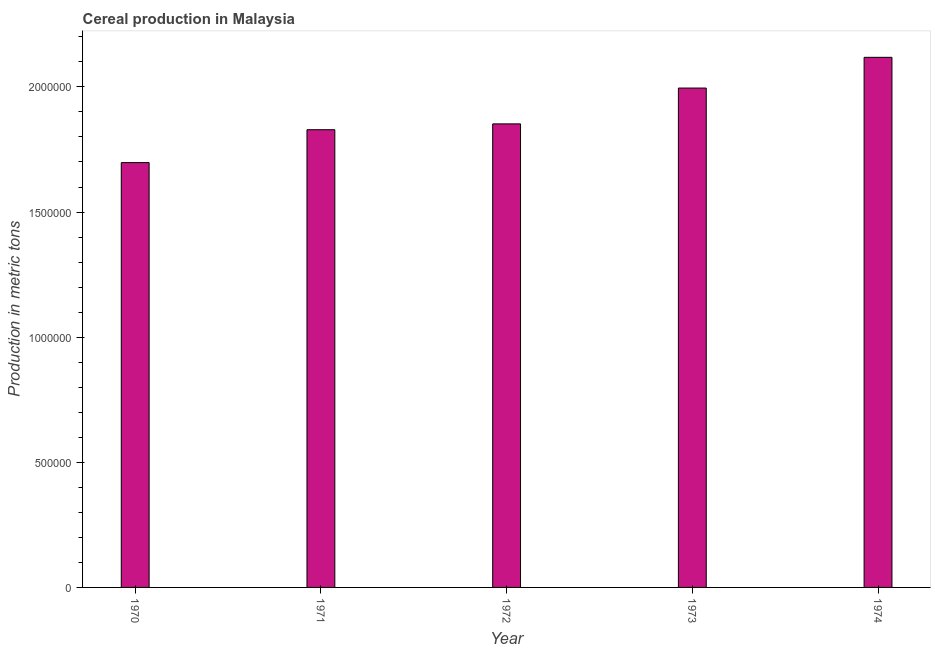Does the graph contain any zero values?
Give a very brief answer. No. What is the title of the graph?
Provide a short and direct response. Cereal production in Malaysia. What is the label or title of the Y-axis?
Provide a succinct answer. Production in metric tons. What is the cereal production in 1970?
Make the answer very short. 1.70e+06. Across all years, what is the maximum cereal production?
Offer a terse response. 2.12e+06. Across all years, what is the minimum cereal production?
Your answer should be compact. 1.70e+06. In which year was the cereal production maximum?
Keep it short and to the point. 1974. What is the sum of the cereal production?
Provide a short and direct response. 9.49e+06. What is the difference between the cereal production in 1971 and 1974?
Your answer should be compact. -2.89e+05. What is the average cereal production per year?
Your answer should be compact. 1.90e+06. What is the median cereal production?
Your answer should be compact. 1.85e+06. What is the ratio of the cereal production in 1973 to that in 1974?
Offer a terse response. 0.94. Is the difference between the cereal production in 1970 and 1972 greater than the difference between any two years?
Your answer should be compact. No. What is the difference between the highest and the second highest cereal production?
Give a very brief answer. 1.23e+05. Is the sum of the cereal production in 1972 and 1974 greater than the maximum cereal production across all years?
Keep it short and to the point. Yes. What is the difference between the highest and the lowest cereal production?
Your answer should be very brief. 4.21e+05. In how many years, is the cereal production greater than the average cereal production taken over all years?
Your answer should be compact. 2. Are all the bars in the graph horizontal?
Offer a terse response. No. How many years are there in the graph?
Your answer should be very brief. 5. What is the difference between two consecutive major ticks on the Y-axis?
Ensure brevity in your answer.  5.00e+05. What is the Production in metric tons of 1970?
Your answer should be very brief. 1.70e+06. What is the Production in metric tons in 1971?
Keep it short and to the point. 1.83e+06. What is the Production in metric tons in 1972?
Make the answer very short. 1.85e+06. What is the Production in metric tons of 1973?
Keep it short and to the point. 2.00e+06. What is the Production in metric tons of 1974?
Your answer should be compact. 2.12e+06. What is the difference between the Production in metric tons in 1970 and 1971?
Keep it short and to the point. -1.31e+05. What is the difference between the Production in metric tons in 1970 and 1972?
Offer a terse response. -1.55e+05. What is the difference between the Production in metric tons in 1970 and 1973?
Ensure brevity in your answer.  -2.98e+05. What is the difference between the Production in metric tons in 1970 and 1974?
Give a very brief answer. -4.21e+05. What is the difference between the Production in metric tons in 1971 and 1972?
Give a very brief answer. -2.33e+04. What is the difference between the Production in metric tons in 1971 and 1973?
Provide a succinct answer. -1.66e+05. What is the difference between the Production in metric tons in 1971 and 1974?
Provide a succinct answer. -2.89e+05. What is the difference between the Production in metric tons in 1972 and 1973?
Ensure brevity in your answer.  -1.43e+05. What is the difference between the Production in metric tons in 1972 and 1974?
Your answer should be very brief. -2.66e+05. What is the difference between the Production in metric tons in 1973 and 1974?
Make the answer very short. -1.23e+05. What is the ratio of the Production in metric tons in 1970 to that in 1971?
Your answer should be compact. 0.93. What is the ratio of the Production in metric tons in 1970 to that in 1972?
Offer a terse response. 0.92. What is the ratio of the Production in metric tons in 1970 to that in 1973?
Make the answer very short. 0.85. What is the ratio of the Production in metric tons in 1970 to that in 1974?
Offer a very short reply. 0.8. What is the ratio of the Production in metric tons in 1971 to that in 1973?
Offer a terse response. 0.92. What is the ratio of the Production in metric tons in 1971 to that in 1974?
Provide a short and direct response. 0.86. What is the ratio of the Production in metric tons in 1972 to that in 1973?
Keep it short and to the point. 0.93. What is the ratio of the Production in metric tons in 1972 to that in 1974?
Provide a short and direct response. 0.87. What is the ratio of the Production in metric tons in 1973 to that in 1974?
Ensure brevity in your answer.  0.94. 